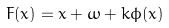Convert formula to latex. <formula><loc_0><loc_0><loc_500><loc_500>F ( x ) = x + \omega + k \phi ( x )</formula> 